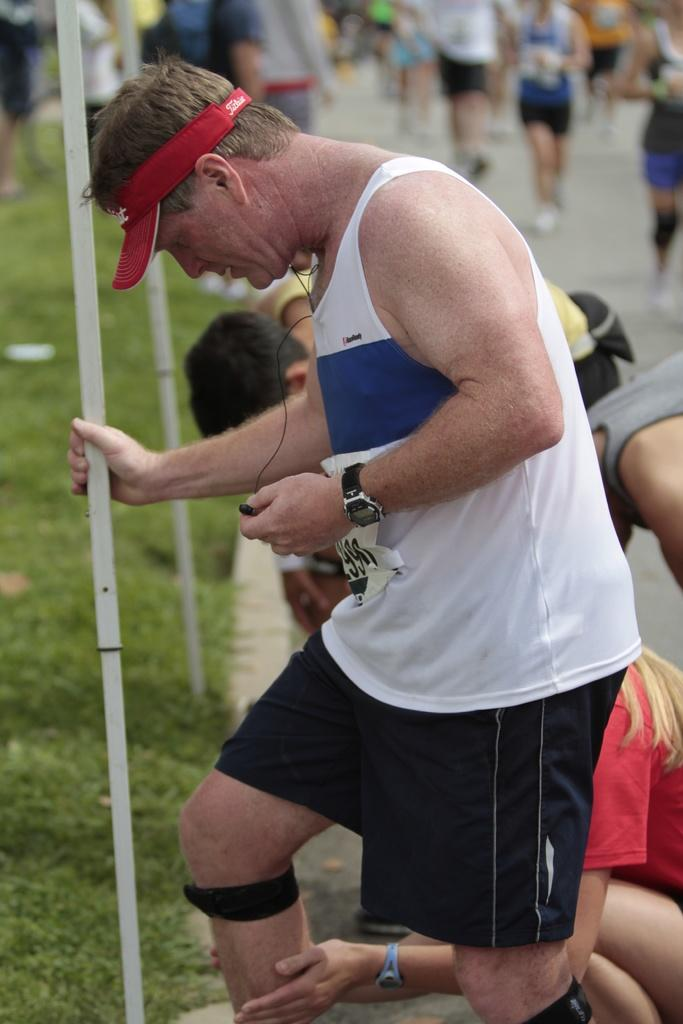What is the person in the image holding? The person is holding a headset. What type of clothing is the person wearing on their head? The person is wearing a cap. What accessory can be seen on the person's wrist? The person is wearing a watch. What type of terrain is visible in the image? There is grass visible in the image. What structures can be seen in the image? There are poles in the image. Can you describe the presence of other people in the image? There are people in the background of the image. What type of porter is serving drinks to the people in the image? There is no porter serving drinks in the image; it only shows a person holding a headset, wearing a cap and watch, with grass and poles in the background, and people in the distance. 